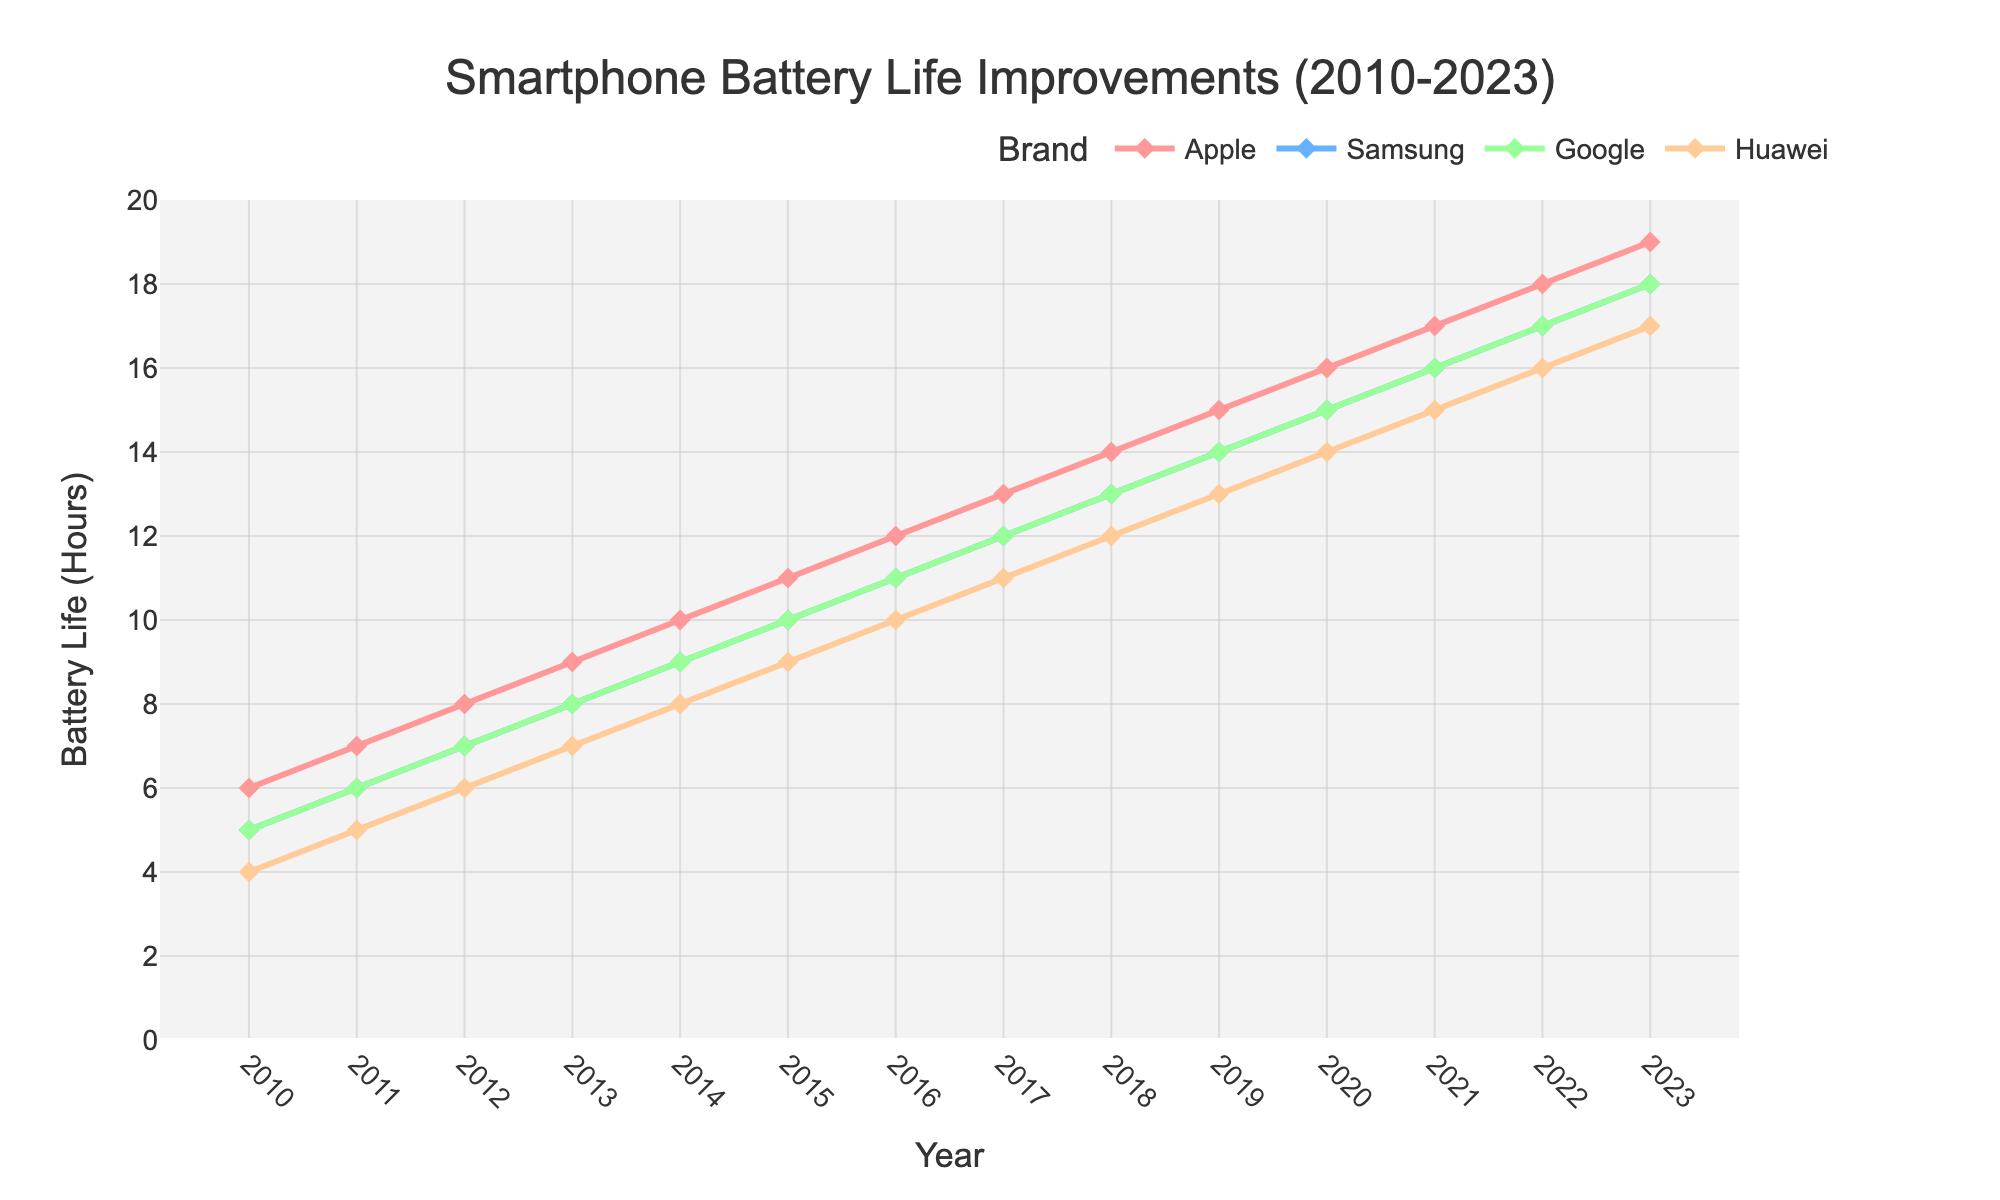What year did Apple surpass 10 hours of average battery life? Find Apple's line on the chart and trace it to where it crosses the 10-hour mark on the y-axis, which happens at 2015.
Answer: 2015 Which brand had the greatest improvement in battery life between 2010 and 2023? Calculate the difference in battery life from 2010 to 2023 for each brand: for Apple (19-6), Samsung (18-5), Google (18-5), and Huawei (17-4). Apple has the greatest increase (13 hours).
Answer: Apple What is the average battery life improvement per year for Samsung? Divide the total improvement by the number of years (2023 - 2010). Samsung's total improvement from 5 to 18 hours is 13 hours over 13 years, making the average improvement 1 hour per year.
Answer: 1 hour per year Between which consecutive years did Huawei see the highest increase in battery life? Find the largest year-on-year difference for Huawei by calculating the differences: (5-4), (6-5), (7-6), etc. The largest increase is from 2010 to 2011, which is 1 hour.
Answer: 2010-2011 As of 2023, how does Google's battery life compare to Samsung's? Both Google and Samsung's lines reach the 18-hour mark by 2023.
Answer: Equal Which brand had the smallest battery life improvement between 2010 and 2015? Calculate the differences for each brand from 2010 to 2015: Apple (11-6), Samsung (10-5), Google (10-5), and Huawei (9-4). Huawei has the smallest increase (5 hours).
Answer: Huawei What color represents Apple on the chart? Identify the color associated with the 'Apple' label in the chart's legend.
Answer: Red By how many years did Apple reach 16 hours of battery life before Samsung? Identify the years when both Apple and Samsung reached 16 hours. Apple in 2020 and Samsung in 2021. Therefore, Apple reached it 1 year earlier.
Answer: 1 year Which brand had the highest battery life in 2013? Compare the battery life values of all brands in 2013. Apple had 9, Samsung had 8, Google had 8, and Huawei had 7. Apple had the highest (9 hours).
Answer: Apple Calculate the median battery life for Google from 2010 to 2023. Sort Google's battery life values (5, 6, 7, ..., 18). With 14 data points, the median is the average of the 7th and 8th values, which are (11+12)/2 = 11.5.
Answer: 11.5 